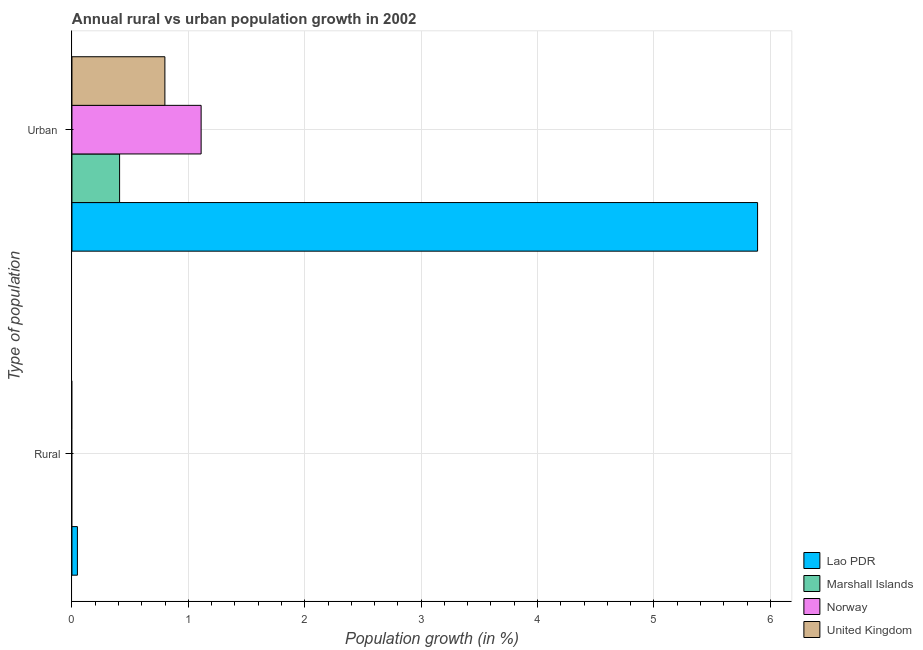Are the number of bars per tick equal to the number of legend labels?
Make the answer very short. No. Are the number of bars on each tick of the Y-axis equal?
Make the answer very short. No. How many bars are there on the 2nd tick from the top?
Provide a short and direct response. 1. What is the label of the 2nd group of bars from the top?
Make the answer very short. Rural. What is the urban population growth in Lao PDR?
Keep it short and to the point. 5.89. Across all countries, what is the maximum urban population growth?
Offer a terse response. 5.89. Across all countries, what is the minimum urban population growth?
Offer a terse response. 0.41. In which country was the rural population growth maximum?
Offer a very short reply. Lao PDR. What is the total rural population growth in the graph?
Your response must be concise. 0.05. What is the difference between the urban population growth in Lao PDR and that in Norway?
Offer a very short reply. 4.78. What is the difference between the rural population growth in Lao PDR and the urban population growth in Marshall Islands?
Your answer should be very brief. -0.36. What is the average rural population growth per country?
Give a very brief answer. 0.01. What is the difference between the urban population growth and rural population growth in Lao PDR?
Keep it short and to the point. 5.84. In how many countries, is the urban population growth greater than 1.2 %?
Make the answer very short. 1. What is the ratio of the urban population growth in Norway to that in Marshall Islands?
Make the answer very short. 2.71. How many countries are there in the graph?
Provide a short and direct response. 4. What is the difference between two consecutive major ticks on the X-axis?
Offer a very short reply. 1. Are the values on the major ticks of X-axis written in scientific E-notation?
Your answer should be compact. No. Does the graph contain any zero values?
Offer a very short reply. Yes. Does the graph contain grids?
Your answer should be very brief. Yes. Where does the legend appear in the graph?
Make the answer very short. Bottom right. How many legend labels are there?
Your response must be concise. 4. What is the title of the graph?
Provide a short and direct response. Annual rural vs urban population growth in 2002. What is the label or title of the X-axis?
Make the answer very short. Population growth (in %). What is the label or title of the Y-axis?
Make the answer very short. Type of population. What is the Population growth (in %) in Lao PDR in Rural?
Make the answer very short. 0.05. What is the Population growth (in %) in Marshall Islands in Rural?
Offer a very short reply. 0. What is the Population growth (in %) in Norway in Rural?
Provide a succinct answer. 0. What is the Population growth (in %) in United Kingdom in Rural?
Your answer should be very brief. 0. What is the Population growth (in %) in Lao PDR in Urban ?
Your answer should be compact. 5.89. What is the Population growth (in %) in Marshall Islands in Urban ?
Your answer should be very brief. 0.41. What is the Population growth (in %) in Norway in Urban ?
Your answer should be very brief. 1.11. What is the Population growth (in %) of United Kingdom in Urban ?
Offer a very short reply. 0.8. Across all Type of population, what is the maximum Population growth (in %) of Lao PDR?
Provide a succinct answer. 5.89. Across all Type of population, what is the maximum Population growth (in %) in Marshall Islands?
Offer a very short reply. 0.41. Across all Type of population, what is the maximum Population growth (in %) of Norway?
Provide a succinct answer. 1.11. Across all Type of population, what is the maximum Population growth (in %) in United Kingdom?
Your answer should be very brief. 0.8. Across all Type of population, what is the minimum Population growth (in %) of Lao PDR?
Your answer should be very brief. 0.05. Across all Type of population, what is the minimum Population growth (in %) in Marshall Islands?
Keep it short and to the point. 0. What is the total Population growth (in %) in Lao PDR in the graph?
Your answer should be compact. 5.94. What is the total Population growth (in %) in Marshall Islands in the graph?
Give a very brief answer. 0.41. What is the total Population growth (in %) in Norway in the graph?
Offer a terse response. 1.11. What is the total Population growth (in %) in United Kingdom in the graph?
Your response must be concise. 0.8. What is the difference between the Population growth (in %) of Lao PDR in Rural and that in Urban ?
Your answer should be very brief. -5.84. What is the difference between the Population growth (in %) in Lao PDR in Rural and the Population growth (in %) in Marshall Islands in Urban ?
Provide a short and direct response. -0.36. What is the difference between the Population growth (in %) in Lao PDR in Rural and the Population growth (in %) in Norway in Urban ?
Make the answer very short. -1.06. What is the difference between the Population growth (in %) of Lao PDR in Rural and the Population growth (in %) of United Kingdom in Urban ?
Offer a very short reply. -0.75. What is the average Population growth (in %) of Lao PDR per Type of population?
Give a very brief answer. 2.97. What is the average Population growth (in %) in Marshall Islands per Type of population?
Your answer should be compact. 0.2. What is the average Population growth (in %) in Norway per Type of population?
Keep it short and to the point. 0.55. What is the average Population growth (in %) of United Kingdom per Type of population?
Make the answer very short. 0.4. What is the difference between the Population growth (in %) of Lao PDR and Population growth (in %) of Marshall Islands in Urban ?
Your response must be concise. 5.48. What is the difference between the Population growth (in %) in Lao PDR and Population growth (in %) in Norway in Urban ?
Provide a short and direct response. 4.78. What is the difference between the Population growth (in %) of Lao PDR and Population growth (in %) of United Kingdom in Urban ?
Offer a terse response. 5.09. What is the difference between the Population growth (in %) of Marshall Islands and Population growth (in %) of Norway in Urban ?
Offer a very short reply. -0.7. What is the difference between the Population growth (in %) of Marshall Islands and Population growth (in %) of United Kingdom in Urban ?
Your response must be concise. -0.39. What is the difference between the Population growth (in %) in Norway and Population growth (in %) in United Kingdom in Urban ?
Offer a very short reply. 0.31. What is the ratio of the Population growth (in %) in Lao PDR in Rural to that in Urban ?
Offer a very short reply. 0.01. What is the difference between the highest and the second highest Population growth (in %) of Lao PDR?
Your answer should be very brief. 5.84. What is the difference between the highest and the lowest Population growth (in %) of Lao PDR?
Ensure brevity in your answer.  5.84. What is the difference between the highest and the lowest Population growth (in %) in Marshall Islands?
Offer a terse response. 0.41. What is the difference between the highest and the lowest Population growth (in %) of Norway?
Give a very brief answer. 1.11. What is the difference between the highest and the lowest Population growth (in %) of United Kingdom?
Provide a succinct answer. 0.8. 